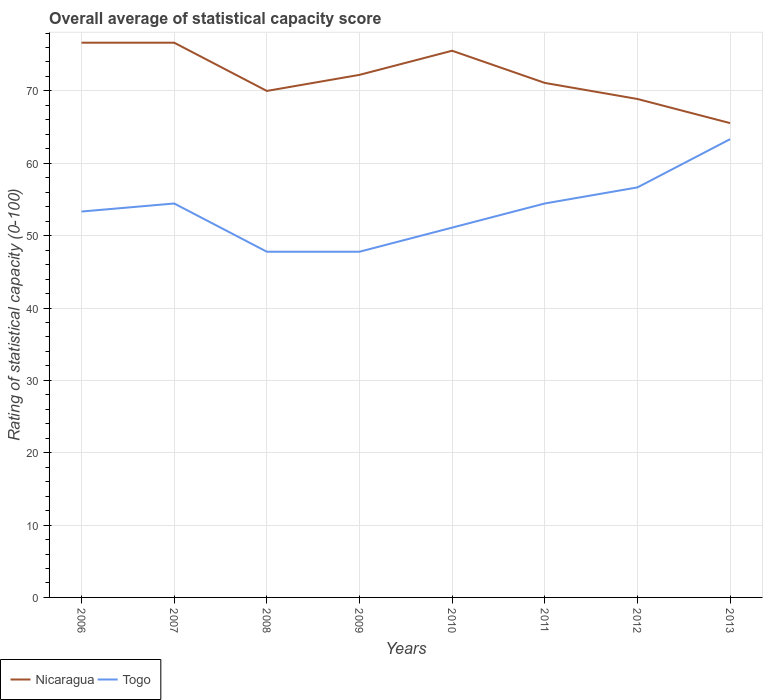How many different coloured lines are there?
Your answer should be compact. 2. Is the number of lines equal to the number of legend labels?
Your response must be concise. Yes. Across all years, what is the maximum rating of statistical capacity in Togo?
Your answer should be very brief. 47.78. In which year was the rating of statistical capacity in Togo maximum?
Keep it short and to the point. 2008. What is the total rating of statistical capacity in Nicaragua in the graph?
Your answer should be compact. 7.78. What is the difference between the highest and the second highest rating of statistical capacity in Togo?
Give a very brief answer. 15.56. How many years are there in the graph?
Give a very brief answer. 8. What is the difference between two consecutive major ticks on the Y-axis?
Ensure brevity in your answer.  10. Are the values on the major ticks of Y-axis written in scientific E-notation?
Your answer should be very brief. No. Does the graph contain grids?
Provide a succinct answer. Yes. Where does the legend appear in the graph?
Your answer should be very brief. Bottom left. How are the legend labels stacked?
Make the answer very short. Horizontal. What is the title of the graph?
Ensure brevity in your answer.  Overall average of statistical capacity score. What is the label or title of the Y-axis?
Your response must be concise. Rating of statistical capacity (0-100). What is the Rating of statistical capacity (0-100) of Nicaragua in 2006?
Make the answer very short. 76.67. What is the Rating of statistical capacity (0-100) of Togo in 2006?
Provide a short and direct response. 53.33. What is the Rating of statistical capacity (0-100) in Nicaragua in 2007?
Offer a terse response. 76.67. What is the Rating of statistical capacity (0-100) in Togo in 2007?
Keep it short and to the point. 54.44. What is the Rating of statistical capacity (0-100) in Togo in 2008?
Provide a short and direct response. 47.78. What is the Rating of statistical capacity (0-100) in Nicaragua in 2009?
Ensure brevity in your answer.  72.22. What is the Rating of statistical capacity (0-100) of Togo in 2009?
Provide a succinct answer. 47.78. What is the Rating of statistical capacity (0-100) of Nicaragua in 2010?
Your response must be concise. 75.56. What is the Rating of statistical capacity (0-100) in Togo in 2010?
Your answer should be compact. 51.11. What is the Rating of statistical capacity (0-100) in Nicaragua in 2011?
Your response must be concise. 71.11. What is the Rating of statistical capacity (0-100) of Togo in 2011?
Your answer should be very brief. 54.44. What is the Rating of statistical capacity (0-100) in Nicaragua in 2012?
Your answer should be compact. 68.89. What is the Rating of statistical capacity (0-100) of Togo in 2012?
Make the answer very short. 56.67. What is the Rating of statistical capacity (0-100) of Nicaragua in 2013?
Your response must be concise. 65.56. What is the Rating of statistical capacity (0-100) in Togo in 2013?
Provide a short and direct response. 63.33. Across all years, what is the maximum Rating of statistical capacity (0-100) in Nicaragua?
Your answer should be compact. 76.67. Across all years, what is the maximum Rating of statistical capacity (0-100) of Togo?
Your answer should be very brief. 63.33. Across all years, what is the minimum Rating of statistical capacity (0-100) of Nicaragua?
Ensure brevity in your answer.  65.56. Across all years, what is the minimum Rating of statistical capacity (0-100) in Togo?
Your answer should be compact. 47.78. What is the total Rating of statistical capacity (0-100) in Nicaragua in the graph?
Your answer should be compact. 576.67. What is the total Rating of statistical capacity (0-100) in Togo in the graph?
Keep it short and to the point. 428.89. What is the difference between the Rating of statistical capacity (0-100) in Nicaragua in 2006 and that in 2007?
Your answer should be compact. 0. What is the difference between the Rating of statistical capacity (0-100) of Togo in 2006 and that in 2007?
Your response must be concise. -1.11. What is the difference between the Rating of statistical capacity (0-100) of Nicaragua in 2006 and that in 2008?
Provide a succinct answer. 6.67. What is the difference between the Rating of statistical capacity (0-100) in Togo in 2006 and that in 2008?
Provide a short and direct response. 5.56. What is the difference between the Rating of statistical capacity (0-100) of Nicaragua in 2006 and that in 2009?
Your response must be concise. 4.44. What is the difference between the Rating of statistical capacity (0-100) in Togo in 2006 and that in 2009?
Provide a succinct answer. 5.56. What is the difference between the Rating of statistical capacity (0-100) of Togo in 2006 and that in 2010?
Your response must be concise. 2.22. What is the difference between the Rating of statistical capacity (0-100) in Nicaragua in 2006 and that in 2011?
Give a very brief answer. 5.56. What is the difference between the Rating of statistical capacity (0-100) in Togo in 2006 and that in 2011?
Your answer should be very brief. -1.11. What is the difference between the Rating of statistical capacity (0-100) of Nicaragua in 2006 and that in 2012?
Your answer should be very brief. 7.78. What is the difference between the Rating of statistical capacity (0-100) in Nicaragua in 2006 and that in 2013?
Make the answer very short. 11.11. What is the difference between the Rating of statistical capacity (0-100) of Togo in 2006 and that in 2013?
Your answer should be compact. -10. What is the difference between the Rating of statistical capacity (0-100) in Nicaragua in 2007 and that in 2009?
Your answer should be compact. 4.44. What is the difference between the Rating of statistical capacity (0-100) in Togo in 2007 and that in 2010?
Ensure brevity in your answer.  3.33. What is the difference between the Rating of statistical capacity (0-100) in Nicaragua in 2007 and that in 2011?
Offer a very short reply. 5.56. What is the difference between the Rating of statistical capacity (0-100) in Togo in 2007 and that in 2011?
Offer a terse response. 0. What is the difference between the Rating of statistical capacity (0-100) of Nicaragua in 2007 and that in 2012?
Provide a succinct answer. 7.78. What is the difference between the Rating of statistical capacity (0-100) in Togo in 2007 and that in 2012?
Your answer should be very brief. -2.22. What is the difference between the Rating of statistical capacity (0-100) in Nicaragua in 2007 and that in 2013?
Your answer should be very brief. 11.11. What is the difference between the Rating of statistical capacity (0-100) in Togo in 2007 and that in 2013?
Your response must be concise. -8.89. What is the difference between the Rating of statistical capacity (0-100) of Nicaragua in 2008 and that in 2009?
Your answer should be very brief. -2.22. What is the difference between the Rating of statistical capacity (0-100) of Togo in 2008 and that in 2009?
Keep it short and to the point. 0. What is the difference between the Rating of statistical capacity (0-100) in Nicaragua in 2008 and that in 2010?
Provide a succinct answer. -5.56. What is the difference between the Rating of statistical capacity (0-100) of Togo in 2008 and that in 2010?
Make the answer very short. -3.33. What is the difference between the Rating of statistical capacity (0-100) in Nicaragua in 2008 and that in 2011?
Make the answer very short. -1.11. What is the difference between the Rating of statistical capacity (0-100) in Togo in 2008 and that in 2011?
Offer a very short reply. -6.67. What is the difference between the Rating of statistical capacity (0-100) in Nicaragua in 2008 and that in 2012?
Ensure brevity in your answer.  1.11. What is the difference between the Rating of statistical capacity (0-100) in Togo in 2008 and that in 2012?
Provide a short and direct response. -8.89. What is the difference between the Rating of statistical capacity (0-100) of Nicaragua in 2008 and that in 2013?
Make the answer very short. 4.44. What is the difference between the Rating of statistical capacity (0-100) in Togo in 2008 and that in 2013?
Your answer should be compact. -15.56. What is the difference between the Rating of statistical capacity (0-100) of Nicaragua in 2009 and that in 2010?
Provide a succinct answer. -3.33. What is the difference between the Rating of statistical capacity (0-100) in Togo in 2009 and that in 2011?
Your answer should be compact. -6.67. What is the difference between the Rating of statistical capacity (0-100) of Nicaragua in 2009 and that in 2012?
Provide a succinct answer. 3.33. What is the difference between the Rating of statistical capacity (0-100) of Togo in 2009 and that in 2012?
Your response must be concise. -8.89. What is the difference between the Rating of statistical capacity (0-100) in Nicaragua in 2009 and that in 2013?
Your answer should be compact. 6.67. What is the difference between the Rating of statistical capacity (0-100) in Togo in 2009 and that in 2013?
Provide a short and direct response. -15.56. What is the difference between the Rating of statistical capacity (0-100) of Nicaragua in 2010 and that in 2011?
Your response must be concise. 4.44. What is the difference between the Rating of statistical capacity (0-100) of Nicaragua in 2010 and that in 2012?
Your answer should be very brief. 6.67. What is the difference between the Rating of statistical capacity (0-100) of Togo in 2010 and that in 2012?
Keep it short and to the point. -5.56. What is the difference between the Rating of statistical capacity (0-100) in Togo in 2010 and that in 2013?
Provide a succinct answer. -12.22. What is the difference between the Rating of statistical capacity (0-100) of Nicaragua in 2011 and that in 2012?
Provide a short and direct response. 2.22. What is the difference between the Rating of statistical capacity (0-100) of Togo in 2011 and that in 2012?
Give a very brief answer. -2.22. What is the difference between the Rating of statistical capacity (0-100) of Nicaragua in 2011 and that in 2013?
Keep it short and to the point. 5.56. What is the difference between the Rating of statistical capacity (0-100) in Togo in 2011 and that in 2013?
Offer a terse response. -8.89. What is the difference between the Rating of statistical capacity (0-100) in Togo in 2012 and that in 2013?
Provide a short and direct response. -6.67. What is the difference between the Rating of statistical capacity (0-100) in Nicaragua in 2006 and the Rating of statistical capacity (0-100) in Togo in 2007?
Keep it short and to the point. 22.22. What is the difference between the Rating of statistical capacity (0-100) of Nicaragua in 2006 and the Rating of statistical capacity (0-100) of Togo in 2008?
Give a very brief answer. 28.89. What is the difference between the Rating of statistical capacity (0-100) in Nicaragua in 2006 and the Rating of statistical capacity (0-100) in Togo in 2009?
Give a very brief answer. 28.89. What is the difference between the Rating of statistical capacity (0-100) of Nicaragua in 2006 and the Rating of statistical capacity (0-100) of Togo in 2010?
Your response must be concise. 25.56. What is the difference between the Rating of statistical capacity (0-100) in Nicaragua in 2006 and the Rating of statistical capacity (0-100) in Togo in 2011?
Your response must be concise. 22.22. What is the difference between the Rating of statistical capacity (0-100) in Nicaragua in 2006 and the Rating of statistical capacity (0-100) in Togo in 2013?
Provide a succinct answer. 13.33. What is the difference between the Rating of statistical capacity (0-100) of Nicaragua in 2007 and the Rating of statistical capacity (0-100) of Togo in 2008?
Offer a very short reply. 28.89. What is the difference between the Rating of statistical capacity (0-100) in Nicaragua in 2007 and the Rating of statistical capacity (0-100) in Togo in 2009?
Provide a short and direct response. 28.89. What is the difference between the Rating of statistical capacity (0-100) in Nicaragua in 2007 and the Rating of statistical capacity (0-100) in Togo in 2010?
Provide a short and direct response. 25.56. What is the difference between the Rating of statistical capacity (0-100) in Nicaragua in 2007 and the Rating of statistical capacity (0-100) in Togo in 2011?
Offer a very short reply. 22.22. What is the difference between the Rating of statistical capacity (0-100) in Nicaragua in 2007 and the Rating of statistical capacity (0-100) in Togo in 2012?
Offer a very short reply. 20. What is the difference between the Rating of statistical capacity (0-100) in Nicaragua in 2007 and the Rating of statistical capacity (0-100) in Togo in 2013?
Make the answer very short. 13.33. What is the difference between the Rating of statistical capacity (0-100) of Nicaragua in 2008 and the Rating of statistical capacity (0-100) of Togo in 2009?
Your answer should be very brief. 22.22. What is the difference between the Rating of statistical capacity (0-100) in Nicaragua in 2008 and the Rating of statistical capacity (0-100) in Togo in 2010?
Offer a terse response. 18.89. What is the difference between the Rating of statistical capacity (0-100) in Nicaragua in 2008 and the Rating of statistical capacity (0-100) in Togo in 2011?
Offer a very short reply. 15.56. What is the difference between the Rating of statistical capacity (0-100) of Nicaragua in 2008 and the Rating of statistical capacity (0-100) of Togo in 2012?
Ensure brevity in your answer.  13.33. What is the difference between the Rating of statistical capacity (0-100) of Nicaragua in 2008 and the Rating of statistical capacity (0-100) of Togo in 2013?
Provide a succinct answer. 6.67. What is the difference between the Rating of statistical capacity (0-100) in Nicaragua in 2009 and the Rating of statistical capacity (0-100) in Togo in 2010?
Provide a succinct answer. 21.11. What is the difference between the Rating of statistical capacity (0-100) in Nicaragua in 2009 and the Rating of statistical capacity (0-100) in Togo in 2011?
Provide a succinct answer. 17.78. What is the difference between the Rating of statistical capacity (0-100) of Nicaragua in 2009 and the Rating of statistical capacity (0-100) of Togo in 2012?
Ensure brevity in your answer.  15.56. What is the difference between the Rating of statistical capacity (0-100) in Nicaragua in 2009 and the Rating of statistical capacity (0-100) in Togo in 2013?
Offer a terse response. 8.89. What is the difference between the Rating of statistical capacity (0-100) of Nicaragua in 2010 and the Rating of statistical capacity (0-100) of Togo in 2011?
Provide a short and direct response. 21.11. What is the difference between the Rating of statistical capacity (0-100) of Nicaragua in 2010 and the Rating of statistical capacity (0-100) of Togo in 2012?
Your response must be concise. 18.89. What is the difference between the Rating of statistical capacity (0-100) in Nicaragua in 2010 and the Rating of statistical capacity (0-100) in Togo in 2013?
Offer a very short reply. 12.22. What is the difference between the Rating of statistical capacity (0-100) of Nicaragua in 2011 and the Rating of statistical capacity (0-100) of Togo in 2012?
Ensure brevity in your answer.  14.44. What is the difference between the Rating of statistical capacity (0-100) in Nicaragua in 2011 and the Rating of statistical capacity (0-100) in Togo in 2013?
Make the answer very short. 7.78. What is the difference between the Rating of statistical capacity (0-100) of Nicaragua in 2012 and the Rating of statistical capacity (0-100) of Togo in 2013?
Provide a short and direct response. 5.56. What is the average Rating of statistical capacity (0-100) in Nicaragua per year?
Keep it short and to the point. 72.08. What is the average Rating of statistical capacity (0-100) of Togo per year?
Ensure brevity in your answer.  53.61. In the year 2006, what is the difference between the Rating of statistical capacity (0-100) in Nicaragua and Rating of statistical capacity (0-100) in Togo?
Provide a short and direct response. 23.33. In the year 2007, what is the difference between the Rating of statistical capacity (0-100) of Nicaragua and Rating of statistical capacity (0-100) of Togo?
Your answer should be compact. 22.22. In the year 2008, what is the difference between the Rating of statistical capacity (0-100) in Nicaragua and Rating of statistical capacity (0-100) in Togo?
Give a very brief answer. 22.22. In the year 2009, what is the difference between the Rating of statistical capacity (0-100) of Nicaragua and Rating of statistical capacity (0-100) of Togo?
Your response must be concise. 24.44. In the year 2010, what is the difference between the Rating of statistical capacity (0-100) of Nicaragua and Rating of statistical capacity (0-100) of Togo?
Keep it short and to the point. 24.44. In the year 2011, what is the difference between the Rating of statistical capacity (0-100) in Nicaragua and Rating of statistical capacity (0-100) in Togo?
Your answer should be compact. 16.67. In the year 2012, what is the difference between the Rating of statistical capacity (0-100) in Nicaragua and Rating of statistical capacity (0-100) in Togo?
Give a very brief answer. 12.22. In the year 2013, what is the difference between the Rating of statistical capacity (0-100) in Nicaragua and Rating of statistical capacity (0-100) in Togo?
Give a very brief answer. 2.22. What is the ratio of the Rating of statistical capacity (0-100) in Togo in 2006 to that in 2007?
Keep it short and to the point. 0.98. What is the ratio of the Rating of statistical capacity (0-100) of Nicaragua in 2006 to that in 2008?
Give a very brief answer. 1.1. What is the ratio of the Rating of statistical capacity (0-100) in Togo in 2006 to that in 2008?
Offer a very short reply. 1.12. What is the ratio of the Rating of statistical capacity (0-100) of Nicaragua in 2006 to that in 2009?
Give a very brief answer. 1.06. What is the ratio of the Rating of statistical capacity (0-100) of Togo in 2006 to that in 2009?
Provide a succinct answer. 1.12. What is the ratio of the Rating of statistical capacity (0-100) of Nicaragua in 2006 to that in 2010?
Give a very brief answer. 1.01. What is the ratio of the Rating of statistical capacity (0-100) in Togo in 2006 to that in 2010?
Your answer should be compact. 1.04. What is the ratio of the Rating of statistical capacity (0-100) of Nicaragua in 2006 to that in 2011?
Make the answer very short. 1.08. What is the ratio of the Rating of statistical capacity (0-100) of Togo in 2006 to that in 2011?
Ensure brevity in your answer.  0.98. What is the ratio of the Rating of statistical capacity (0-100) of Nicaragua in 2006 to that in 2012?
Give a very brief answer. 1.11. What is the ratio of the Rating of statistical capacity (0-100) of Togo in 2006 to that in 2012?
Your answer should be very brief. 0.94. What is the ratio of the Rating of statistical capacity (0-100) in Nicaragua in 2006 to that in 2013?
Give a very brief answer. 1.17. What is the ratio of the Rating of statistical capacity (0-100) in Togo in 2006 to that in 2013?
Your answer should be very brief. 0.84. What is the ratio of the Rating of statistical capacity (0-100) of Nicaragua in 2007 to that in 2008?
Keep it short and to the point. 1.1. What is the ratio of the Rating of statistical capacity (0-100) in Togo in 2007 to that in 2008?
Make the answer very short. 1.14. What is the ratio of the Rating of statistical capacity (0-100) of Nicaragua in 2007 to that in 2009?
Your answer should be compact. 1.06. What is the ratio of the Rating of statistical capacity (0-100) in Togo in 2007 to that in 2009?
Your answer should be very brief. 1.14. What is the ratio of the Rating of statistical capacity (0-100) of Nicaragua in 2007 to that in 2010?
Your answer should be compact. 1.01. What is the ratio of the Rating of statistical capacity (0-100) of Togo in 2007 to that in 2010?
Offer a terse response. 1.07. What is the ratio of the Rating of statistical capacity (0-100) of Nicaragua in 2007 to that in 2011?
Offer a very short reply. 1.08. What is the ratio of the Rating of statistical capacity (0-100) in Togo in 2007 to that in 2011?
Your answer should be very brief. 1. What is the ratio of the Rating of statistical capacity (0-100) of Nicaragua in 2007 to that in 2012?
Provide a succinct answer. 1.11. What is the ratio of the Rating of statistical capacity (0-100) in Togo in 2007 to that in 2012?
Your answer should be very brief. 0.96. What is the ratio of the Rating of statistical capacity (0-100) in Nicaragua in 2007 to that in 2013?
Provide a short and direct response. 1.17. What is the ratio of the Rating of statistical capacity (0-100) of Togo in 2007 to that in 2013?
Provide a succinct answer. 0.86. What is the ratio of the Rating of statistical capacity (0-100) of Nicaragua in 2008 to that in 2009?
Your response must be concise. 0.97. What is the ratio of the Rating of statistical capacity (0-100) of Nicaragua in 2008 to that in 2010?
Offer a terse response. 0.93. What is the ratio of the Rating of statistical capacity (0-100) of Togo in 2008 to that in 2010?
Give a very brief answer. 0.93. What is the ratio of the Rating of statistical capacity (0-100) of Nicaragua in 2008 to that in 2011?
Your answer should be very brief. 0.98. What is the ratio of the Rating of statistical capacity (0-100) in Togo in 2008 to that in 2011?
Ensure brevity in your answer.  0.88. What is the ratio of the Rating of statistical capacity (0-100) of Nicaragua in 2008 to that in 2012?
Offer a very short reply. 1.02. What is the ratio of the Rating of statistical capacity (0-100) of Togo in 2008 to that in 2012?
Your response must be concise. 0.84. What is the ratio of the Rating of statistical capacity (0-100) in Nicaragua in 2008 to that in 2013?
Your answer should be very brief. 1.07. What is the ratio of the Rating of statistical capacity (0-100) of Togo in 2008 to that in 2013?
Offer a terse response. 0.75. What is the ratio of the Rating of statistical capacity (0-100) of Nicaragua in 2009 to that in 2010?
Give a very brief answer. 0.96. What is the ratio of the Rating of statistical capacity (0-100) of Togo in 2009 to that in 2010?
Your answer should be very brief. 0.93. What is the ratio of the Rating of statistical capacity (0-100) in Nicaragua in 2009 to that in 2011?
Give a very brief answer. 1.02. What is the ratio of the Rating of statistical capacity (0-100) of Togo in 2009 to that in 2011?
Offer a very short reply. 0.88. What is the ratio of the Rating of statistical capacity (0-100) of Nicaragua in 2009 to that in 2012?
Provide a short and direct response. 1.05. What is the ratio of the Rating of statistical capacity (0-100) of Togo in 2009 to that in 2012?
Make the answer very short. 0.84. What is the ratio of the Rating of statistical capacity (0-100) in Nicaragua in 2009 to that in 2013?
Your response must be concise. 1.1. What is the ratio of the Rating of statistical capacity (0-100) of Togo in 2009 to that in 2013?
Provide a short and direct response. 0.75. What is the ratio of the Rating of statistical capacity (0-100) of Togo in 2010 to that in 2011?
Ensure brevity in your answer.  0.94. What is the ratio of the Rating of statistical capacity (0-100) of Nicaragua in 2010 to that in 2012?
Offer a very short reply. 1.1. What is the ratio of the Rating of statistical capacity (0-100) of Togo in 2010 to that in 2012?
Provide a succinct answer. 0.9. What is the ratio of the Rating of statistical capacity (0-100) in Nicaragua in 2010 to that in 2013?
Your response must be concise. 1.15. What is the ratio of the Rating of statistical capacity (0-100) in Togo in 2010 to that in 2013?
Ensure brevity in your answer.  0.81. What is the ratio of the Rating of statistical capacity (0-100) of Nicaragua in 2011 to that in 2012?
Make the answer very short. 1.03. What is the ratio of the Rating of statistical capacity (0-100) in Togo in 2011 to that in 2012?
Your response must be concise. 0.96. What is the ratio of the Rating of statistical capacity (0-100) of Nicaragua in 2011 to that in 2013?
Make the answer very short. 1.08. What is the ratio of the Rating of statistical capacity (0-100) in Togo in 2011 to that in 2013?
Provide a short and direct response. 0.86. What is the ratio of the Rating of statistical capacity (0-100) of Nicaragua in 2012 to that in 2013?
Offer a terse response. 1.05. What is the ratio of the Rating of statistical capacity (0-100) of Togo in 2012 to that in 2013?
Keep it short and to the point. 0.89. What is the difference between the highest and the second highest Rating of statistical capacity (0-100) in Nicaragua?
Your response must be concise. 0. What is the difference between the highest and the lowest Rating of statistical capacity (0-100) in Nicaragua?
Provide a short and direct response. 11.11. What is the difference between the highest and the lowest Rating of statistical capacity (0-100) in Togo?
Give a very brief answer. 15.56. 